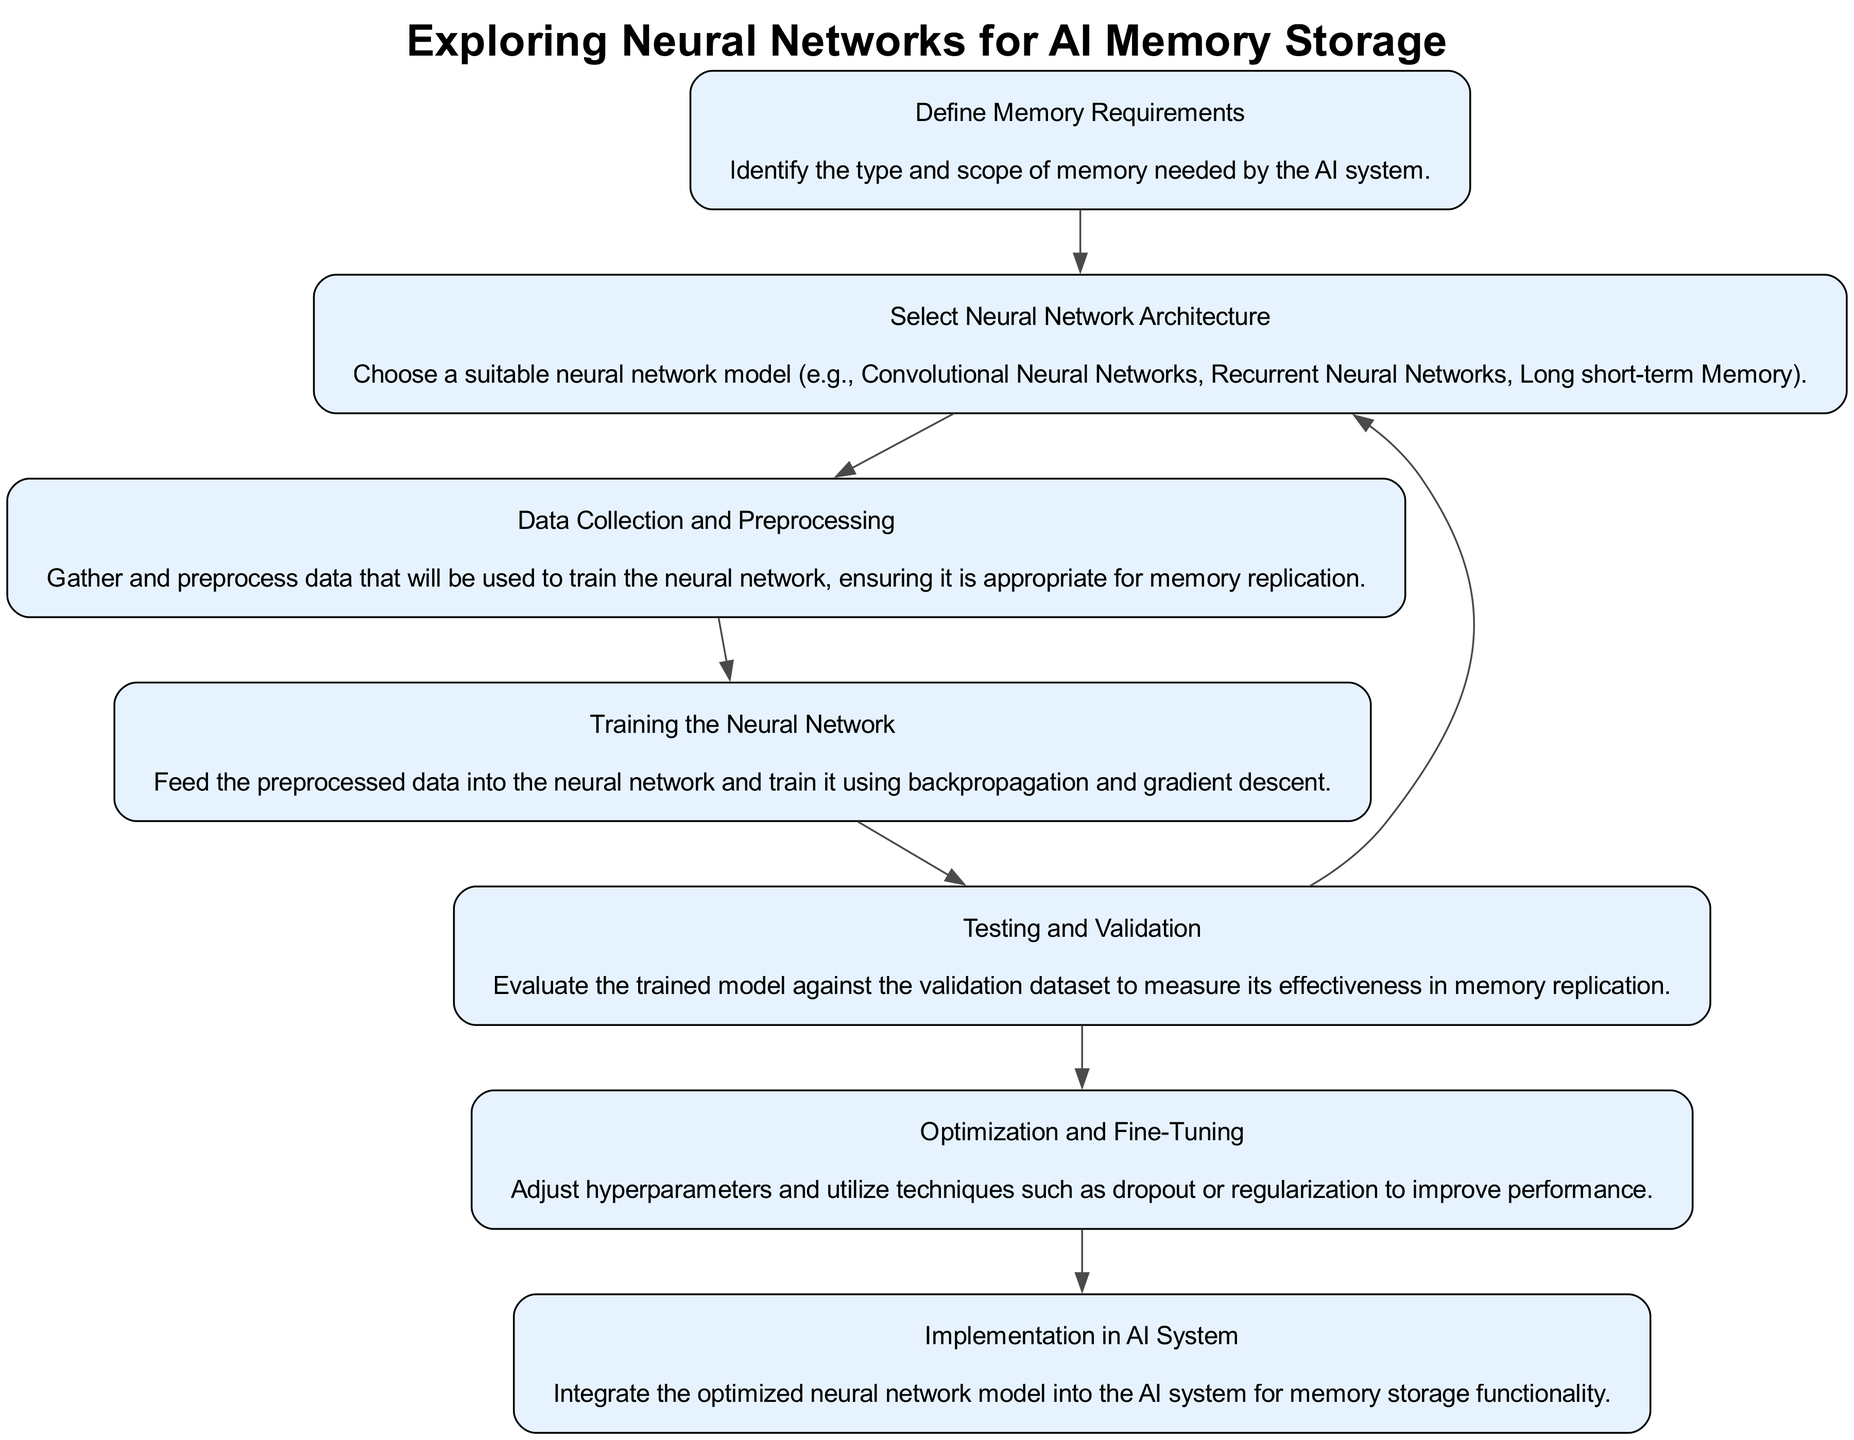What is the first step in the flow chart? The first step is to define memory requirements, which is the initial action needed to identify what memory the AI system requires.
Answer: Define Memory Requirements How many nodes are present in the diagram? By counting all unique steps represented in the diagram, there are a total of seven nodes detailing the steps for exploring neural networks for AI memory storage.
Answer: Seven What node follows "Select Neural Network Architecture"? The next step following "Select Neural Network Architecture" is "Data Collection and Preprocessing," which indicates the flow of actions starts moving towards preparing data after selecting the architecture.
Answer: Data Collection and Preprocessing Which node has two outgoing edges? The "Testing and Validation" node has two outgoing edges, meaning it can lead to either "Optimization and Fine-Tuning" or return to "Select Neural Network Architecture."
Answer: Testing and Validation What is the primary goal of the "Training the Neural Network" step? The primary goal is to feed the preprocessed data into the neural network and train it using backpropagation and gradient descent methods, essential for teaching the model.
Answer: Train the Neural Network How is the "Implementation in AI System" connected in the flow? "Implementation in AI System" is the concluding step of the flow chart and has no outgoing edges, signifying that it's the final stage after all previous steps have been completed.
Answer: No outgoing edges Which step directly follows "Optimization and Fine-Tuning"? The step that directly follows "Optimization and Fine-Tuning" is "Implementation in AI System," indicating that once optimization is complete, integration into the AI system occurs next.
Answer: Implementation in AI System 